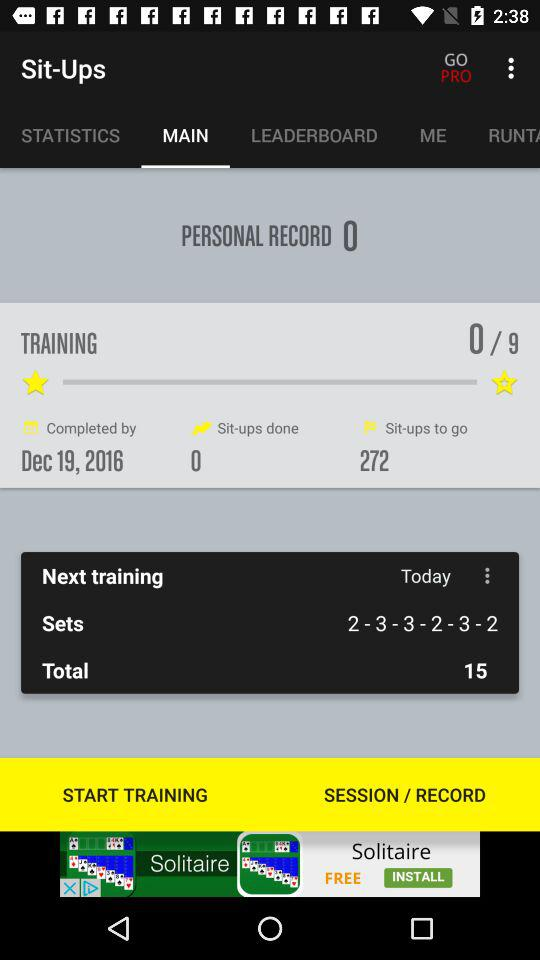What is the date of next training?
When the provided information is insufficient, respond with <no answer>. <no answer> 